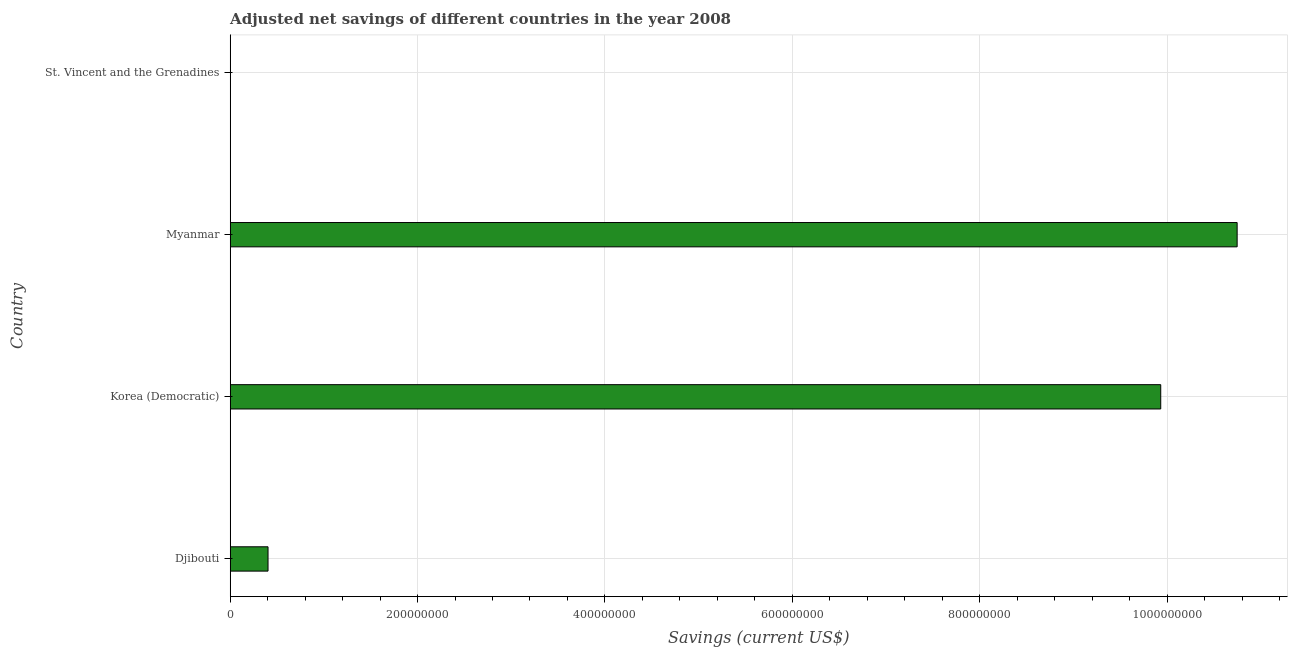Does the graph contain any zero values?
Give a very brief answer. No. Does the graph contain grids?
Offer a very short reply. Yes. What is the title of the graph?
Provide a succinct answer. Adjusted net savings of different countries in the year 2008. What is the label or title of the X-axis?
Your response must be concise. Savings (current US$). What is the adjusted net savings in Djibouti?
Offer a terse response. 4.04e+07. Across all countries, what is the maximum adjusted net savings?
Offer a terse response. 1.07e+09. Across all countries, what is the minimum adjusted net savings?
Offer a terse response. 5.81e+04. In which country was the adjusted net savings maximum?
Provide a succinct answer. Myanmar. In which country was the adjusted net savings minimum?
Give a very brief answer. St. Vincent and the Grenadines. What is the sum of the adjusted net savings?
Keep it short and to the point. 2.11e+09. What is the difference between the adjusted net savings in Korea (Democratic) and Myanmar?
Your response must be concise. -8.16e+07. What is the average adjusted net savings per country?
Your answer should be compact. 5.27e+08. What is the median adjusted net savings?
Provide a succinct answer. 5.17e+08. What is the ratio of the adjusted net savings in Djibouti to that in St. Vincent and the Grenadines?
Provide a short and direct response. 695.26. What is the difference between the highest and the second highest adjusted net savings?
Ensure brevity in your answer.  8.16e+07. What is the difference between the highest and the lowest adjusted net savings?
Give a very brief answer. 1.07e+09. What is the difference between two consecutive major ticks on the X-axis?
Give a very brief answer. 2.00e+08. Are the values on the major ticks of X-axis written in scientific E-notation?
Give a very brief answer. No. What is the Savings (current US$) in Djibouti?
Make the answer very short. 4.04e+07. What is the Savings (current US$) of Korea (Democratic)?
Provide a short and direct response. 9.93e+08. What is the Savings (current US$) of Myanmar?
Keep it short and to the point. 1.07e+09. What is the Savings (current US$) in St. Vincent and the Grenadines?
Your response must be concise. 5.81e+04. What is the difference between the Savings (current US$) in Djibouti and Korea (Democratic)?
Give a very brief answer. -9.53e+08. What is the difference between the Savings (current US$) in Djibouti and Myanmar?
Your answer should be very brief. -1.03e+09. What is the difference between the Savings (current US$) in Djibouti and St. Vincent and the Grenadines?
Give a very brief answer. 4.03e+07. What is the difference between the Savings (current US$) in Korea (Democratic) and Myanmar?
Offer a terse response. -8.16e+07. What is the difference between the Savings (current US$) in Korea (Democratic) and St. Vincent and the Grenadines?
Your answer should be compact. 9.93e+08. What is the difference between the Savings (current US$) in Myanmar and St. Vincent and the Grenadines?
Provide a short and direct response. 1.07e+09. What is the ratio of the Savings (current US$) in Djibouti to that in Korea (Democratic)?
Provide a short and direct response. 0.04. What is the ratio of the Savings (current US$) in Djibouti to that in Myanmar?
Offer a terse response. 0.04. What is the ratio of the Savings (current US$) in Djibouti to that in St. Vincent and the Grenadines?
Your response must be concise. 695.26. What is the ratio of the Savings (current US$) in Korea (Democratic) to that in Myanmar?
Provide a succinct answer. 0.92. What is the ratio of the Savings (current US$) in Korea (Democratic) to that in St. Vincent and the Grenadines?
Give a very brief answer. 1.71e+04. What is the ratio of the Savings (current US$) in Myanmar to that in St. Vincent and the Grenadines?
Keep it short and to the point. 1.85e+04. 